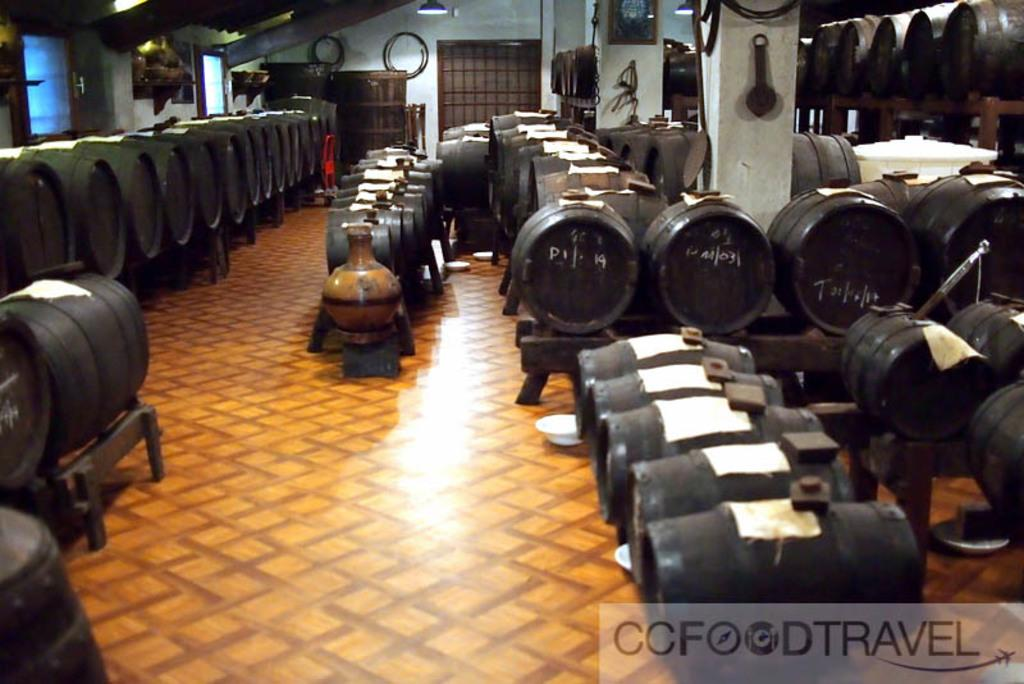What type of containers are present in the image? There are barrels and pots in the image. What material can be seen in the image? There are wooden materials in the image. What architectural features are visible in the background of the image? There is a door and a light in the background of the image. Where are the windows located in the image? The windows are on the left side of the image. What type of pancake is being served by the expert in the image? There is no pancake or expert present in the image. What type of truck can be seen in the image? There is no truck visible in the image. 